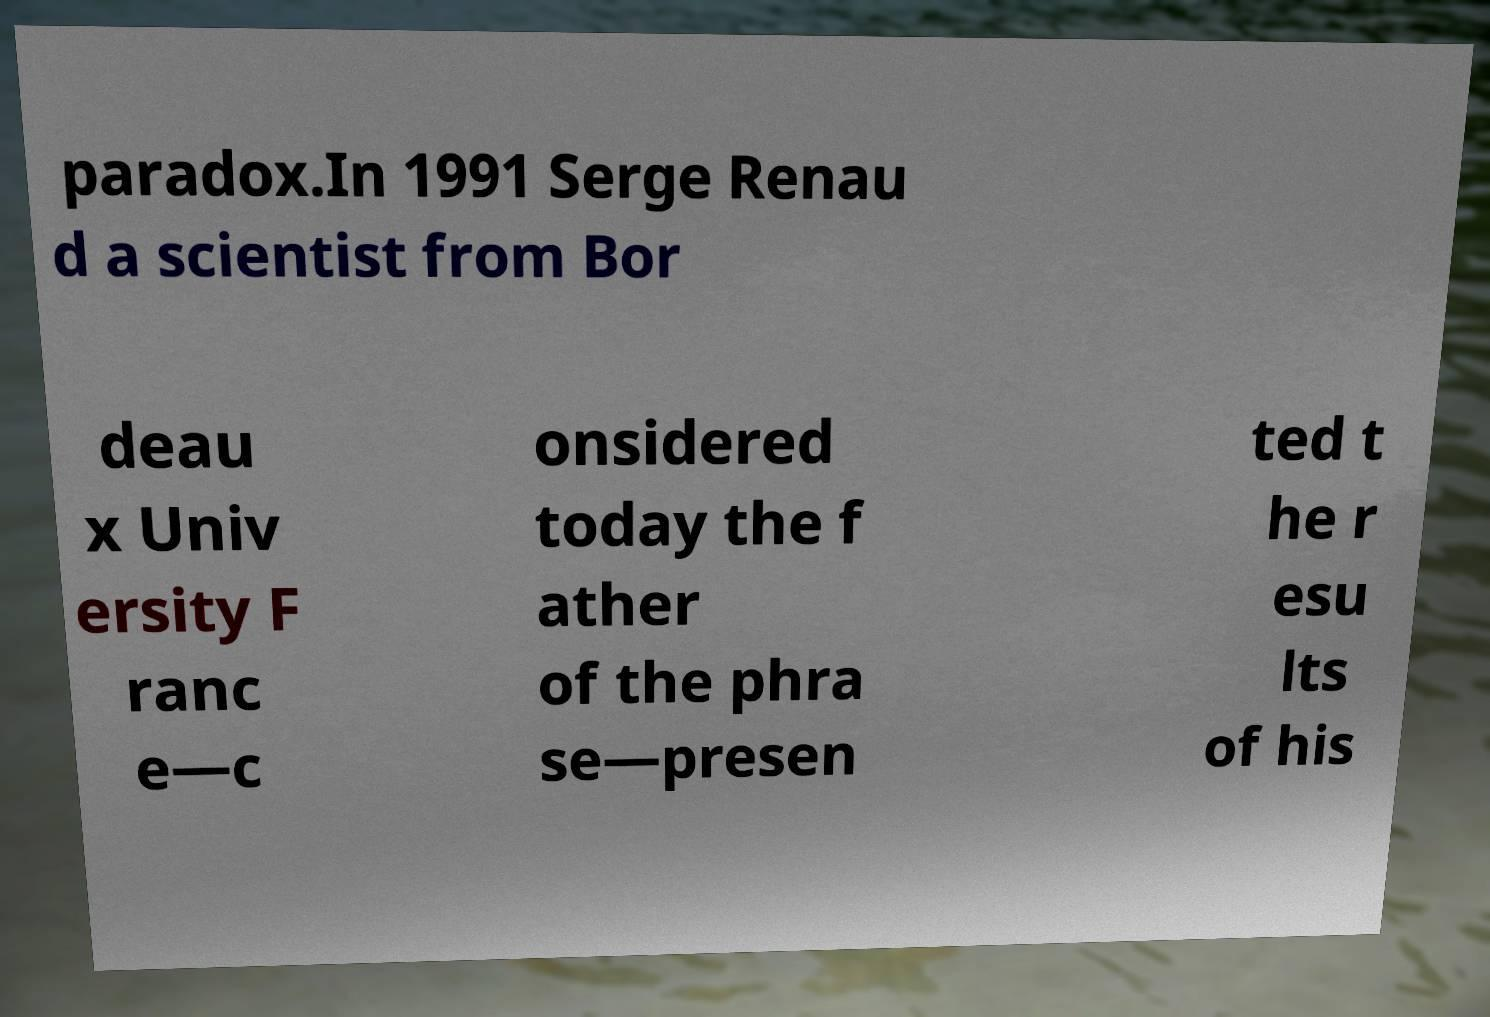For documentation purposes, I need the text within this image transcribed. Could you provide that? paradox.In 1991 Serge Renau d a scientist from Bor deau x Univ ersity F ranc e—c onsidered today the f ather of the phra se—presen ted t he r esu lts of his 